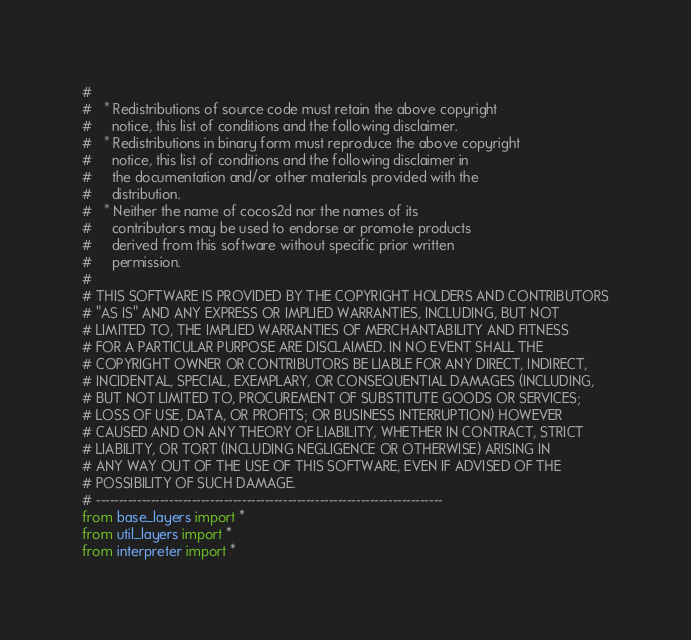<code> <loc_0><loc_0><loc_500><loc_500><_Python_>#
#   * Redistributions of source code must retain the above copyright
#     notice, this list of conditions and the following disclaimer.
#   * Redistributions in binary form must reproduce the above copyright 
#     notice, this list of conditions and the following disclaimer in
#     the documentation and/or other materials provided with the
#     distribution.
#   * Neither the name of cocos2d nor the names of its
#     contributors may be used to endorse or promote products
#     derived from this software without specific prior written
#     permission.
#
# THIS SOFTWARE IS PROVIDED BY THE COPYRIGHT HOLDERS AND CONTRIBUTORS
# "AS IS" AND ANY EXPRESS OR IMPLIED WARRANTIES, INCLUDING, BUT NOT
# LIMITED TO, THE IMPLIED WARRANTIES OF MERCHANTABILITY AND FITNESS
# FOR A PARTICULAR PURPOSE ARE DISCLAIMED. IN NO EVENT SHALL THE
# COPYRIGHT OWNER OR CONTRIBUTORS BE LIABLE FOR ANY DIRECT, INDIRECT,
# INCIDENTAL, SPECIAL, EXEMPLARY, OR CONSEQUENTIAL DAMAGES (INCLUDING,
# BUT NOT LIMITED TO, PROCUREMENT OF SUBSTITUTE GOODS OR SERVICES;
# LOSS OF USE, DATA, OR PROFITS; OR BUSINESS INTERRUPTION) HOWEVER
# CAUSED AND ON ANY THEORY OF LIABILITY, WHETHER IN CONTRACT, STRICT
# LIABILITY, OR TORT (INCLUDING NEGLIGENCE OR OTHERWISE) ARISING IN
# ANY WAY OUT OF THE USE OF THIS SOFTWARE, EVEN IF ADVISED OF THE
# POSSIBILITY OF SUCH DAMAGE.
# ----------------------------------------------------------------------------
from base_layers import *
from util_layers import *
from interpreter import *
</code> 